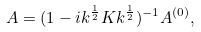<formula> <loc_0><loc_0><loc_500><loc_500>A = ( 1 - i k ^ { \frac { 1 } { 2 } } K k ^ { \frac { 1 } { 2 } } ) ^ { - 1 } A ^ { ( 0 ) } ,</formula> 